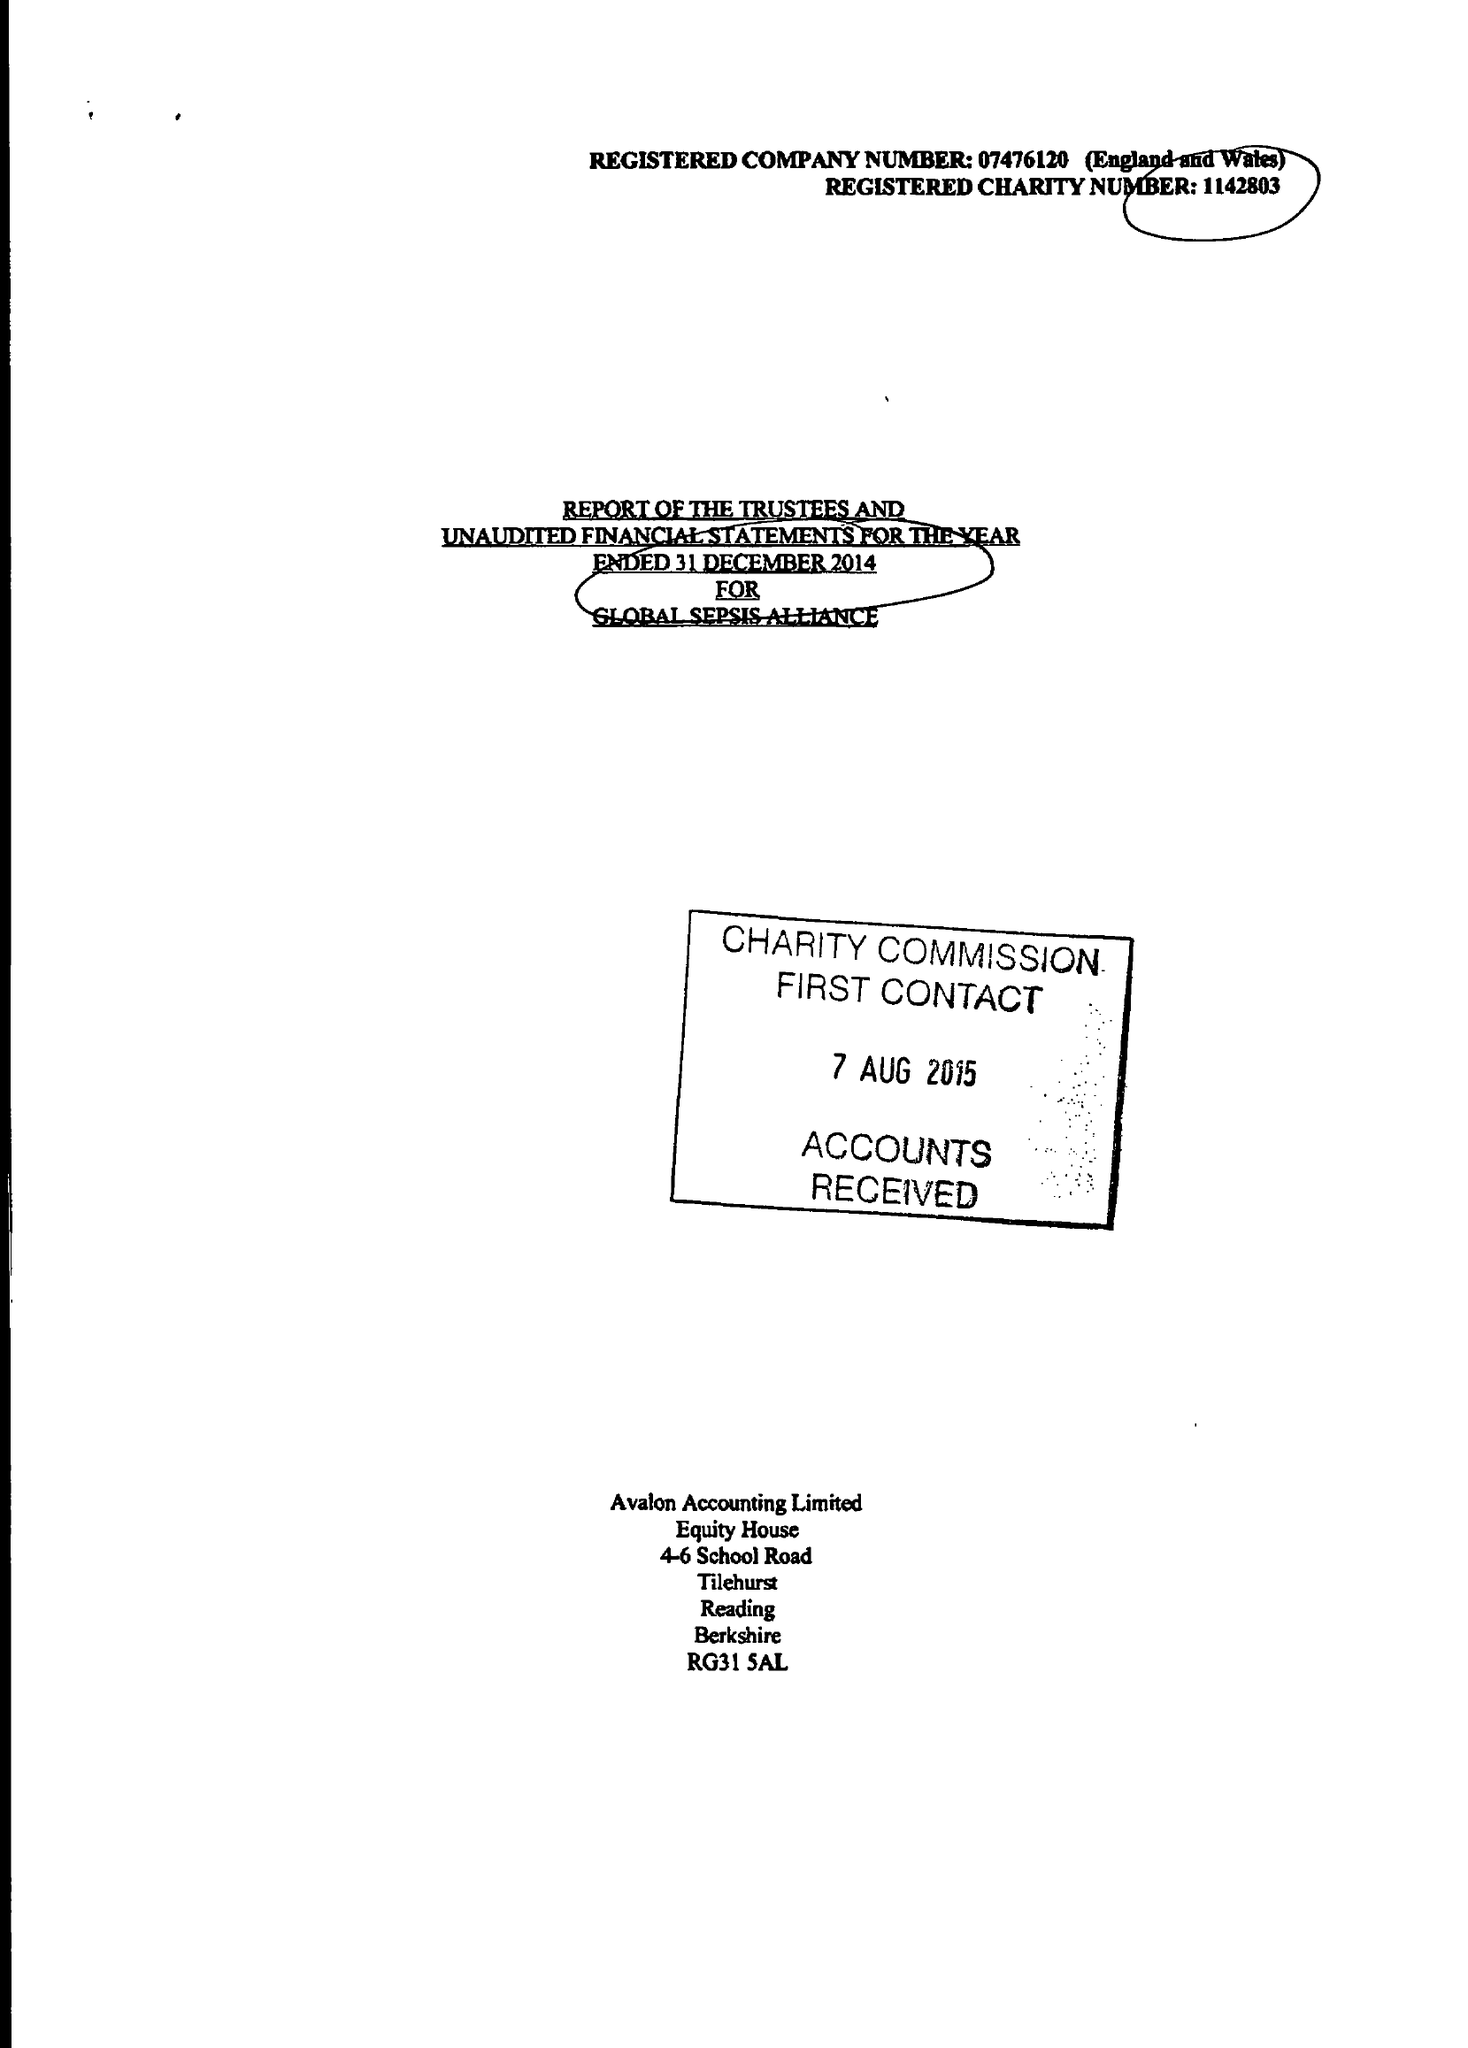What is the value for the address__postcode?
Answer the question using a single word or phrase. RG7 2PZ 